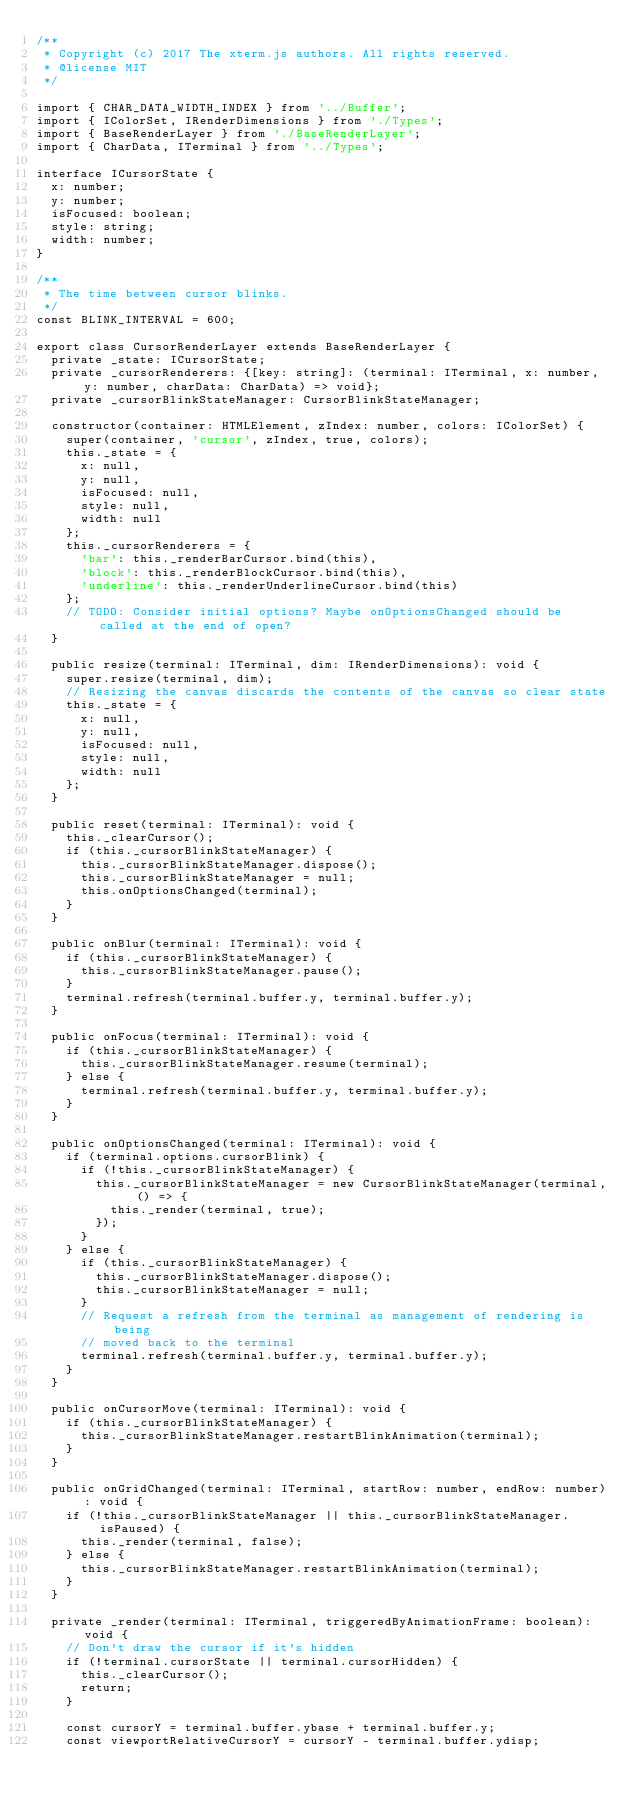Convert code to text. <code><loc_0><loc_0><loc_500><loc_500><_TypeScript_>/**
 * Copyright (c) 2017 The xterm.js authors. All rights reserved.
 * @license MIT
 */

import { CHAR_DATA_WIDTH_INDEX } from '../Buffer';
import { IColorSet, IRenderDimensions } from './Types';
import { BaseRenderLayer } from './BaseRenderLayer';
import { CharData, ITerminal } from '../Types';

interface ICursorState {
  x: number;
  y: number;
  isFocused: boolean;
  style: string;
  width: number;
}

/**
 * The time between cursor blinks.
 */
const BLINK_INTERVAL = 600;

export class CursorRenderLayer extends BaseRenderLayer {
  private _state: ICursorState;
  private _cursorRenderers: {[key: string]: (terminal: ITerminal, x: number, y: number, charData: CharData) => void};
  private _cursorBlinkStateManager: CursorBlinkStateManager;

  constructor(container: HTMLElement, zIndex: number, colors: IColorSet) {
    super(container, 'cursor', zIndex, true, colors);
    this._state = {
      x: null,
      y: null,
      isFocused: null,
      style: null,
      width: null
    };
    this._cursorRenderers = {
      'bar': this._renderBarCursor.bind(this),
      'block': this._renderBlockCursor.bind(this),
      'underline': this._renderUnderlineCursor.bind(this)
    };
    // TODO: Consider initial options? Maybe onOptionsChanged should be called at the end of open?
  }

  public resize(terminal: ITerminal, dim: IRenderDimensions): void {
    super.resize(terminal, dim);
    // Resizing the canvas discards the contents of the canvas so clear state
    this._state = {
      x: null,
      y: null,
      isFocused: null,
      style: null,
      width: null
    };
  }

  public reset(terminal: ITerminal): void {
    this._clearCursor();
    if (this._cursorBlinkStateManager) {
      this._cursorBlinkStateManager.dispose();
      this._cursorBlinkStateManager = null;
      this.onOptionsChanged(terminal);
    }
  }

  public onBlur(terminal: ITerminal): void {
    if (this._cursorBlinkStateManager) {
      this._cursorBlinkStateManager.pause();
    }
    terminal.refresh(terminal.buffer.y, terminal.buffer.y);
  }

  public onFocus(terminal: ITerminal): void {
    if (this._cursorBlinkStateManager) {
      this._cursorBlinkStateManager.resume(terminal);
    } else {
      terminal.refresh(terminal.buffer.y, terminal.buffer.y);
    }
  }

  public onOptionsChanged(terminal: ITerminal): void {
    if (terminal.options.cursorBlink) {
      if (!this._cursorBlinkStateManager) {
        this._cursorBlinkStateManager = new CursorBlinkStateManager(terminal, () => {
          this._render(terminal, true);
        });
      }
    } else {
      if (this._cursorBlinkStateManager) {
        this._cursorBlinkStateManager.dispose();
        this._cursorBlinkStateManager = null;
      }
      // Request a refresh from the terminal as management of rendering is being
      // moved back to the terminal
      terminal.refresh(terminal.buffer.y, terminal.buffer.y);
    }
  }

  public onCursorMove(terminal: ITerminal): void {
    if (this._cursorBlinkStateManager) {
      this._cursorBlinkStateManager.restartBlinkAnimation(terminal);
    }
  }

  public onGridChanged(terminal: ITerminal, startRow: number, endRow: number): void {
    if (!this._cursorBlinkStateManager || this._cursorBlinkStateManager.isPaused) {
      this._render(terminal, false);
    } else {
      this._cursorBlinkStateManager.restartBlinkAnimation(terminal);
    }
  }

  private _render(terminal: ITerminal, triggeredByAnimationFrame: boolean): void {
    // Don't draw the cursor if it's hidden
    if (!terminal.cursorState || terminal.cursorHidden) {
      this._clearCursor();
      return;
    }

    const cursorY = terminal.buffer.ybase + terminal.buffer.y;
    const viewportRelativeCursorY = cursorY - terminal.buffer.ydisp;
</code> 